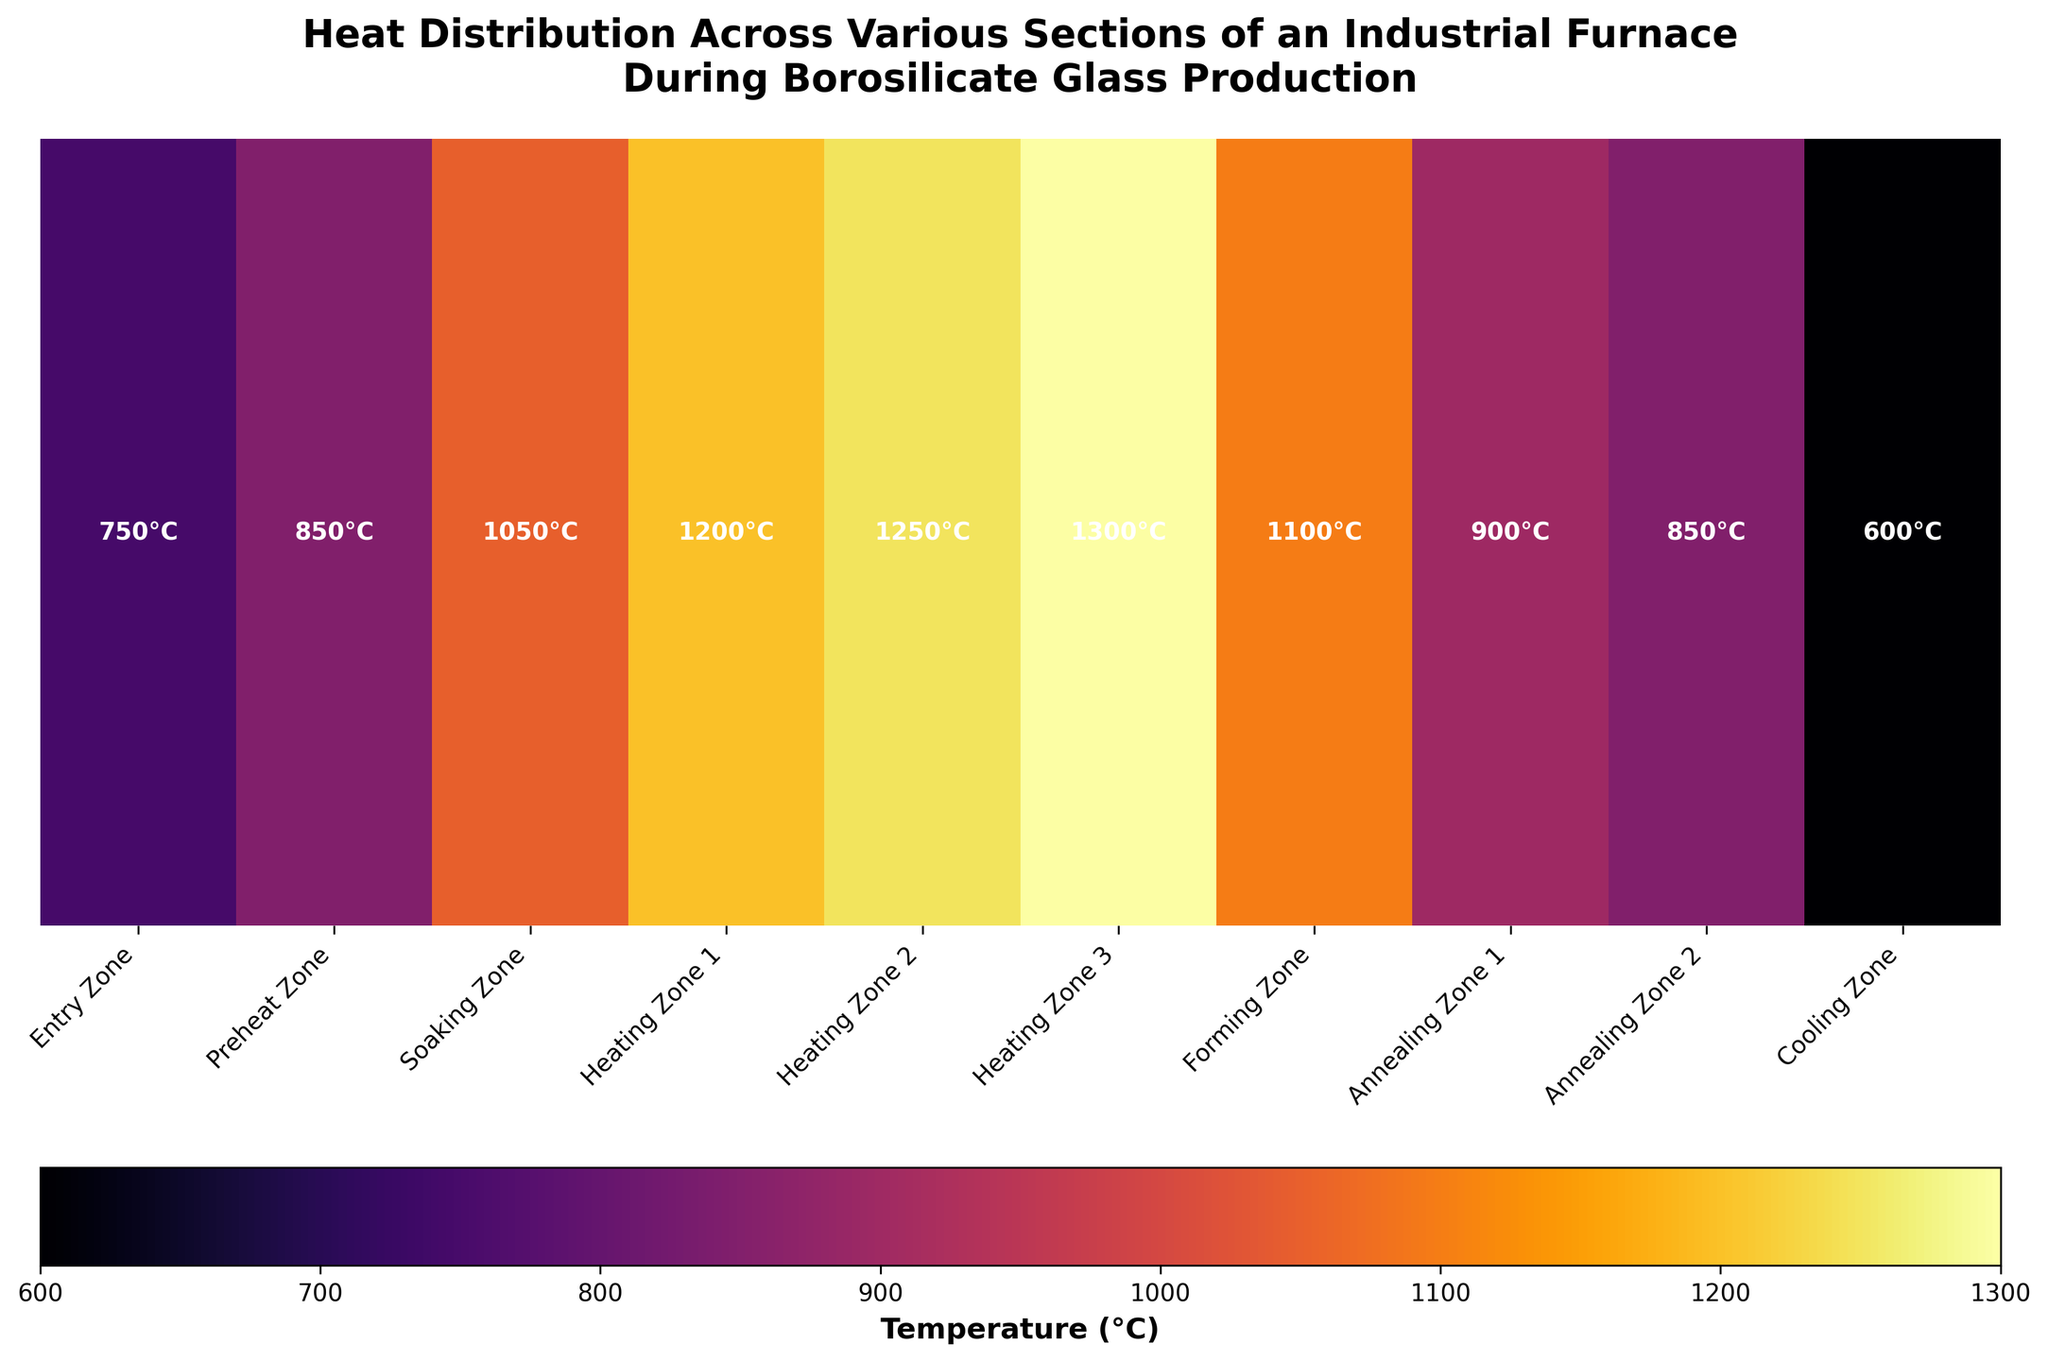What is the highest temperature recorded in the heatmap? The highest temperature can be identified by looking at the labels in the heatmap. The maximum value is 1300°C in the Heating Zone 3.
Answer: 1300°C How many sections have temperatures above 1000°C? The sections with temperatures above 1000°C can be determined by checking each section's temperature label. The sections are Soaking Zone (1050°C), Heating Zone 1 (1200°C), Heating Zone 2 (1250°C), Heating Zone 3 (1300°C), and Forming Zone (1100°C), giving a total of 5 sections.
Answer: 5 Which section has the lowest temperature? The lowest temperature in the heatmap can be identified from the temperature labels. The lowest value is 600°C in the Cooling Zone.
Answer: Cooling Zone What is the temperature difference between the Entry Zone and Heating Zone 3? The temperature of the Entry Zone is 750°C, and the temperature of Heating Zone 3 is 1300°C. The difference is calculated as 1300°C - 750°C = 550°C.
Answer: 550°C Compare the temperatures of the two Annealing Zones. Which one has a higher temperature? The temperatures of Annealing Zone 1 and Annealing Zone 2 are 900°C and 850°C, respectively. Annealing Zone 1 has a higher temperature.
Answer: Annealing Zone 1 What is the average temperature of the zones between the Soaking Zone and the Cooling Zone? The zones between the Soaking Zone and the Cooling Zone are Heating Zone 1, Heating Zone 2, Heating Zone 3, Forming Zone, Annealing Zone 1, and Annealing Zone 2. Their temperatures are 1200°C, 1250°C, 1300°C, 1100°C, 900°C, and 850°C. The average is (1200 + 1250 + 1300 + 1100 + 900 + 850) / 6 = 1083.33°C.
Answer: 1083.33°C Which section shows the closest temperature to 1000°C and what is the exact value? By referring to the temperature labels, the Soaking Zone shows the closest temperature to 1000°C, with an exact value of 1050°C.
Answer: Soaking Zone, 1050°C Which sections have temperatures within the range of 800°C to 900°C? The sections within this temperature range are Preheat Zone (850°C) and Annealing Zone 1 (900°C).
Answer: Preheat Zone, Annealing Zone 1 